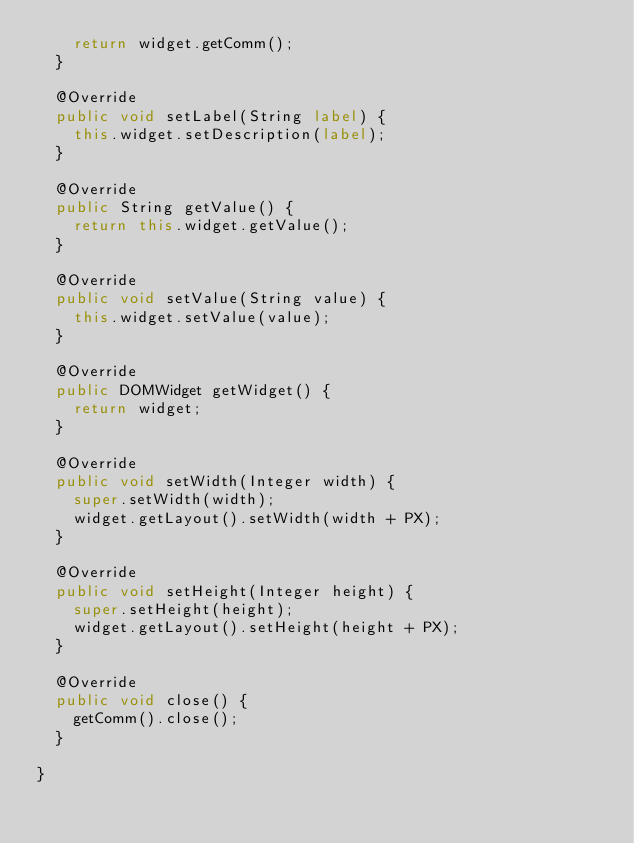Convert code to text. <code><loc_0><loc_0><loc_500><loc_500><_Java_>    return widget.getComm();
  }

  @Override
  public void setLabel(String label) {
    this.widget.setDescription(label);
  }

  @Override
  public String getValue() {
    return this.widget.getValue();
  }

  @Override
  public void setValue(String value) {
    this.widget.setValue(value);
  }

  @Override
  public DOMWidget getWidget() {
    return widget;
  }

  @Override
  public void setWidth(Integer width) {
    super.setWidth(width);
    widget.getLayout().setWidth(width + PX);
  }

  @Override
  public void setHeight(Integer height) {
    super.setHeight(height);
    widget.getLayout().setHeight(height + PX);
  }
  
  @Override
  public void close() {
    getComm().close();
  }
  
}</code> 